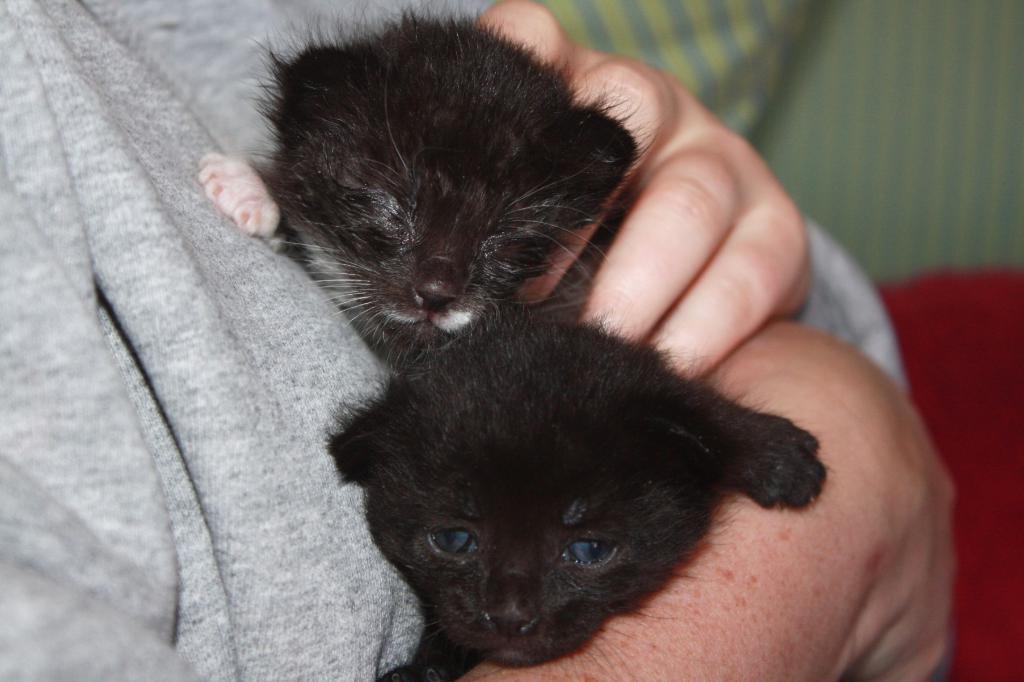How would you summarize this image in a sentence or two? This image consists of a person wearing gray t-shirt is holding two cats. In the background, there are clothes in red and green color. 